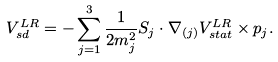Convert formula to latex. <formula><loc_0><loc_0><loc_500><loc_500>V _ { s d } ^ { L R } = - \sum _ { j = 1 } ^ { 3 } \frac { 1 } { 2 m _ { j } ^ { 2 } } S _ { j } \cdot \nabla _ { ( j ) } V _ { s t a t } ^ { L R } \times p _ { j } .</formula> 